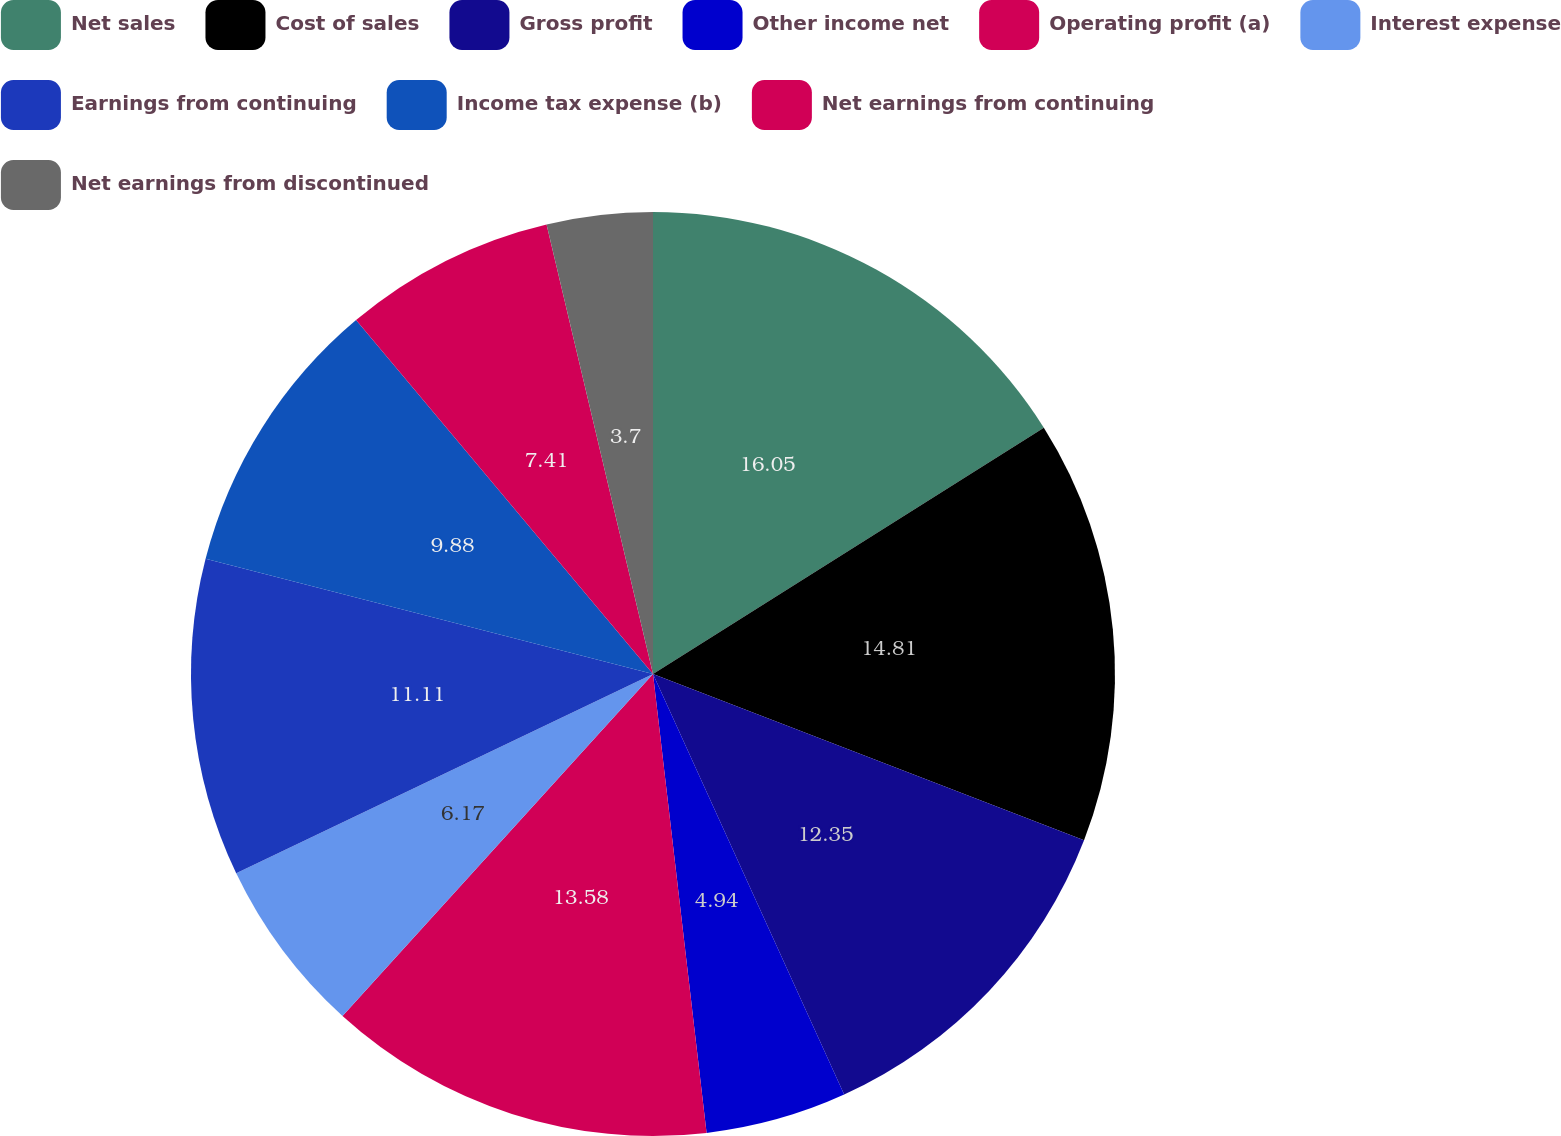Convert chart to OTSL. <chart><loc_0><loc_0><loc_500><loc_500><pie_chart><fcel>Net sales<fcel>Cost of sales<fcel>Gross profit<fcel>Other income net<fcel>Operating profit (a)<fcel>Interest expense<fcel>Earnings from continuing<fcel>Income tax expense (b)<fcel>Net earnings from continuing<fcel>Net earnings from discontinued<nl><fcel>16.05%<fcel>14.81%<fcel>12.35%<fcel>4.94%<fcel>13.58%<fcel>6.17%<fcel>11.11%<fcel>9.88%<fcel>7.41%<fcel>3.7%<nl></chart> 